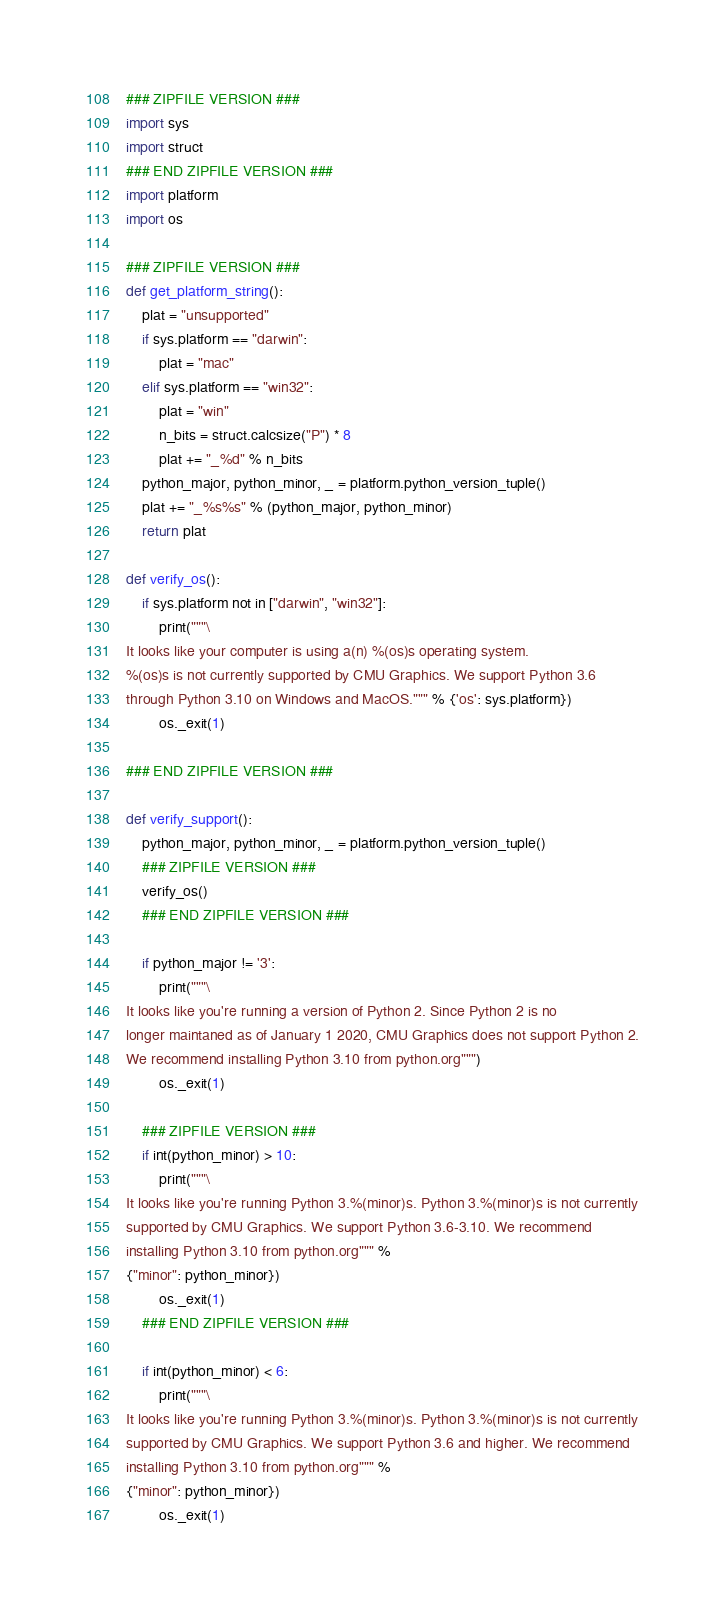Convert code to text. <code><loc_0><loc_0><loc_500><loc_500><_Python_>### ZIPFILE VERSION ###
import sys
import struct
### END ZIPFILE VERSION ###
import platform
import os

### ZIPFILE VERSION ###
def get_platform_string():
    plat = "unsupported"
    if sys.platform == "darwin":
        plat = "mac"
    elif sys.platform == "win32":
        plat = "win"
        n_bits = struct.calcsize("P") * 8
        plat += "_%d" % n_bits
    python_major, python_minor, _ = platform.python_version_tuple()
    plat += "_%s%s" % (python_major, python_minor)
    return plat

def verify_os():
    if sys.platform not in ["darwin", "win32"]:
        print("""\
It looks like your computer is using a(n) %(os)s operating system.
%(os)s is not currently supported by CMU Graphics. We support Python 3.6
through Python 3.10 on Windows and MacOS.""" % {'os': sys.platform})
        os._exit(1)
        
### END ZIPFILE VERSION ###

def verify_support():
    python_major, python_minor, _ = platform.python_version_tuple()
    ### ZIPFILE VERSION ###
    verify_os()
    ### END ZIPFILE VERSION ###

    if python_major != '3':
        print("""\
It looks like you're running a version of Python 2. Since Python 2 is no
longer maintaned as of January 1 2020, CMU Graphics does not support Python 2.
We recommend installing Python 3.10 from python.org""")
        os._exit(1)

    ### ZIPFILE VERSION ###
    if int(python_minor) > 10:
        print("""\
It looks like you're running Python 3.%(minor)s. Python 3.%(minor)s is not currently
supported by CMU Graphics. We support Python 3.6-3.10. We recommend
installing Python 3.10 from python.org""" %
{"minor": python_minor})
        os._exit(1)
    ### END ZIPFILE VERSION ###

    if int(python_minor) < 6:
        print("""\
It looks like you're running Python 3.%(minor)s. Python 3.%(minor)s is not currently
supported by CMU Graphics. We support Python 3.6 and higher. We recommend 
installing Python 3.10 from python.org""" %
{"minor": python_minor})
        os._exit(1)
</code> 